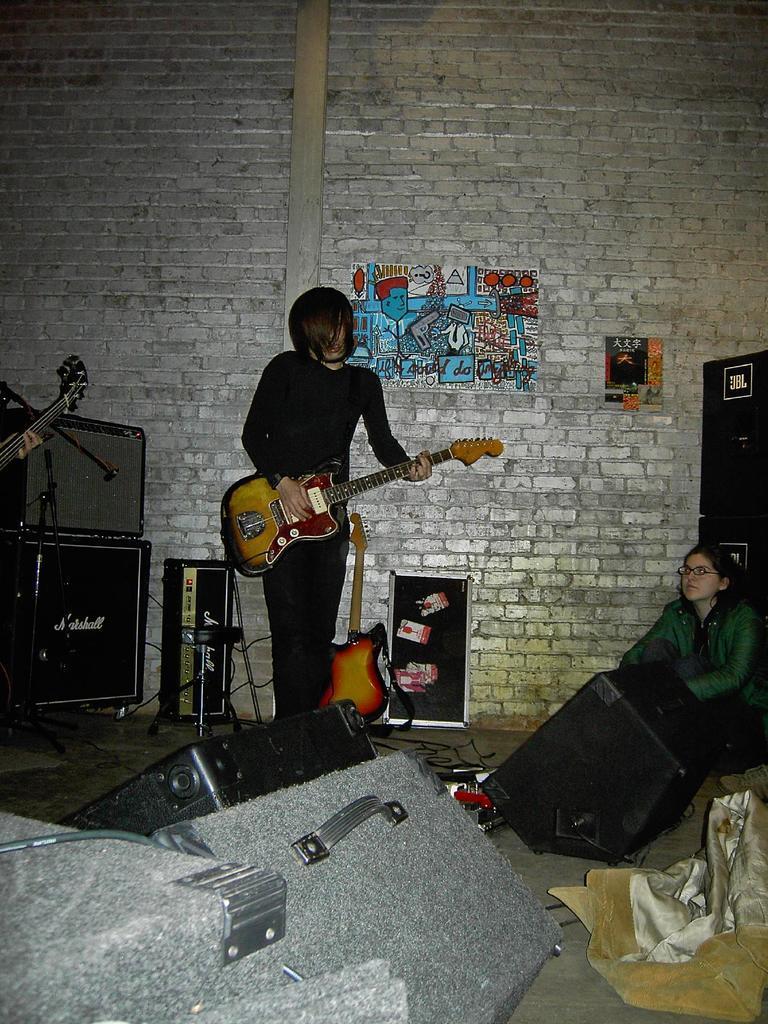Can you describe this image briefly? In this image we can see a boy is standing and playing guitar. Right side of the image one girl is sitting, she is wearing green color jacket. Bottom of the image some things are there. Background brick wall is there. On wall one poster is attached. Left side of the image one square shape black color box is there. 